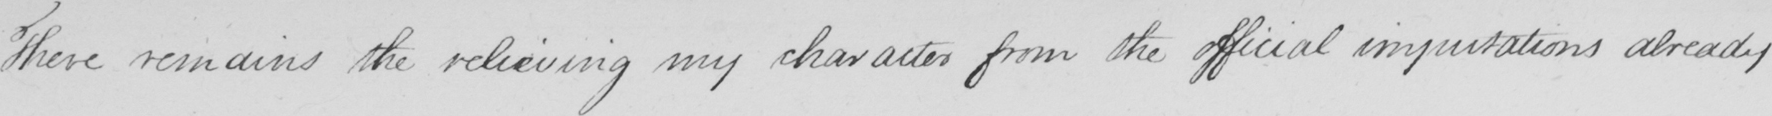What is written in this line of handwriting? There remains the relieving my character from the official imputations already 